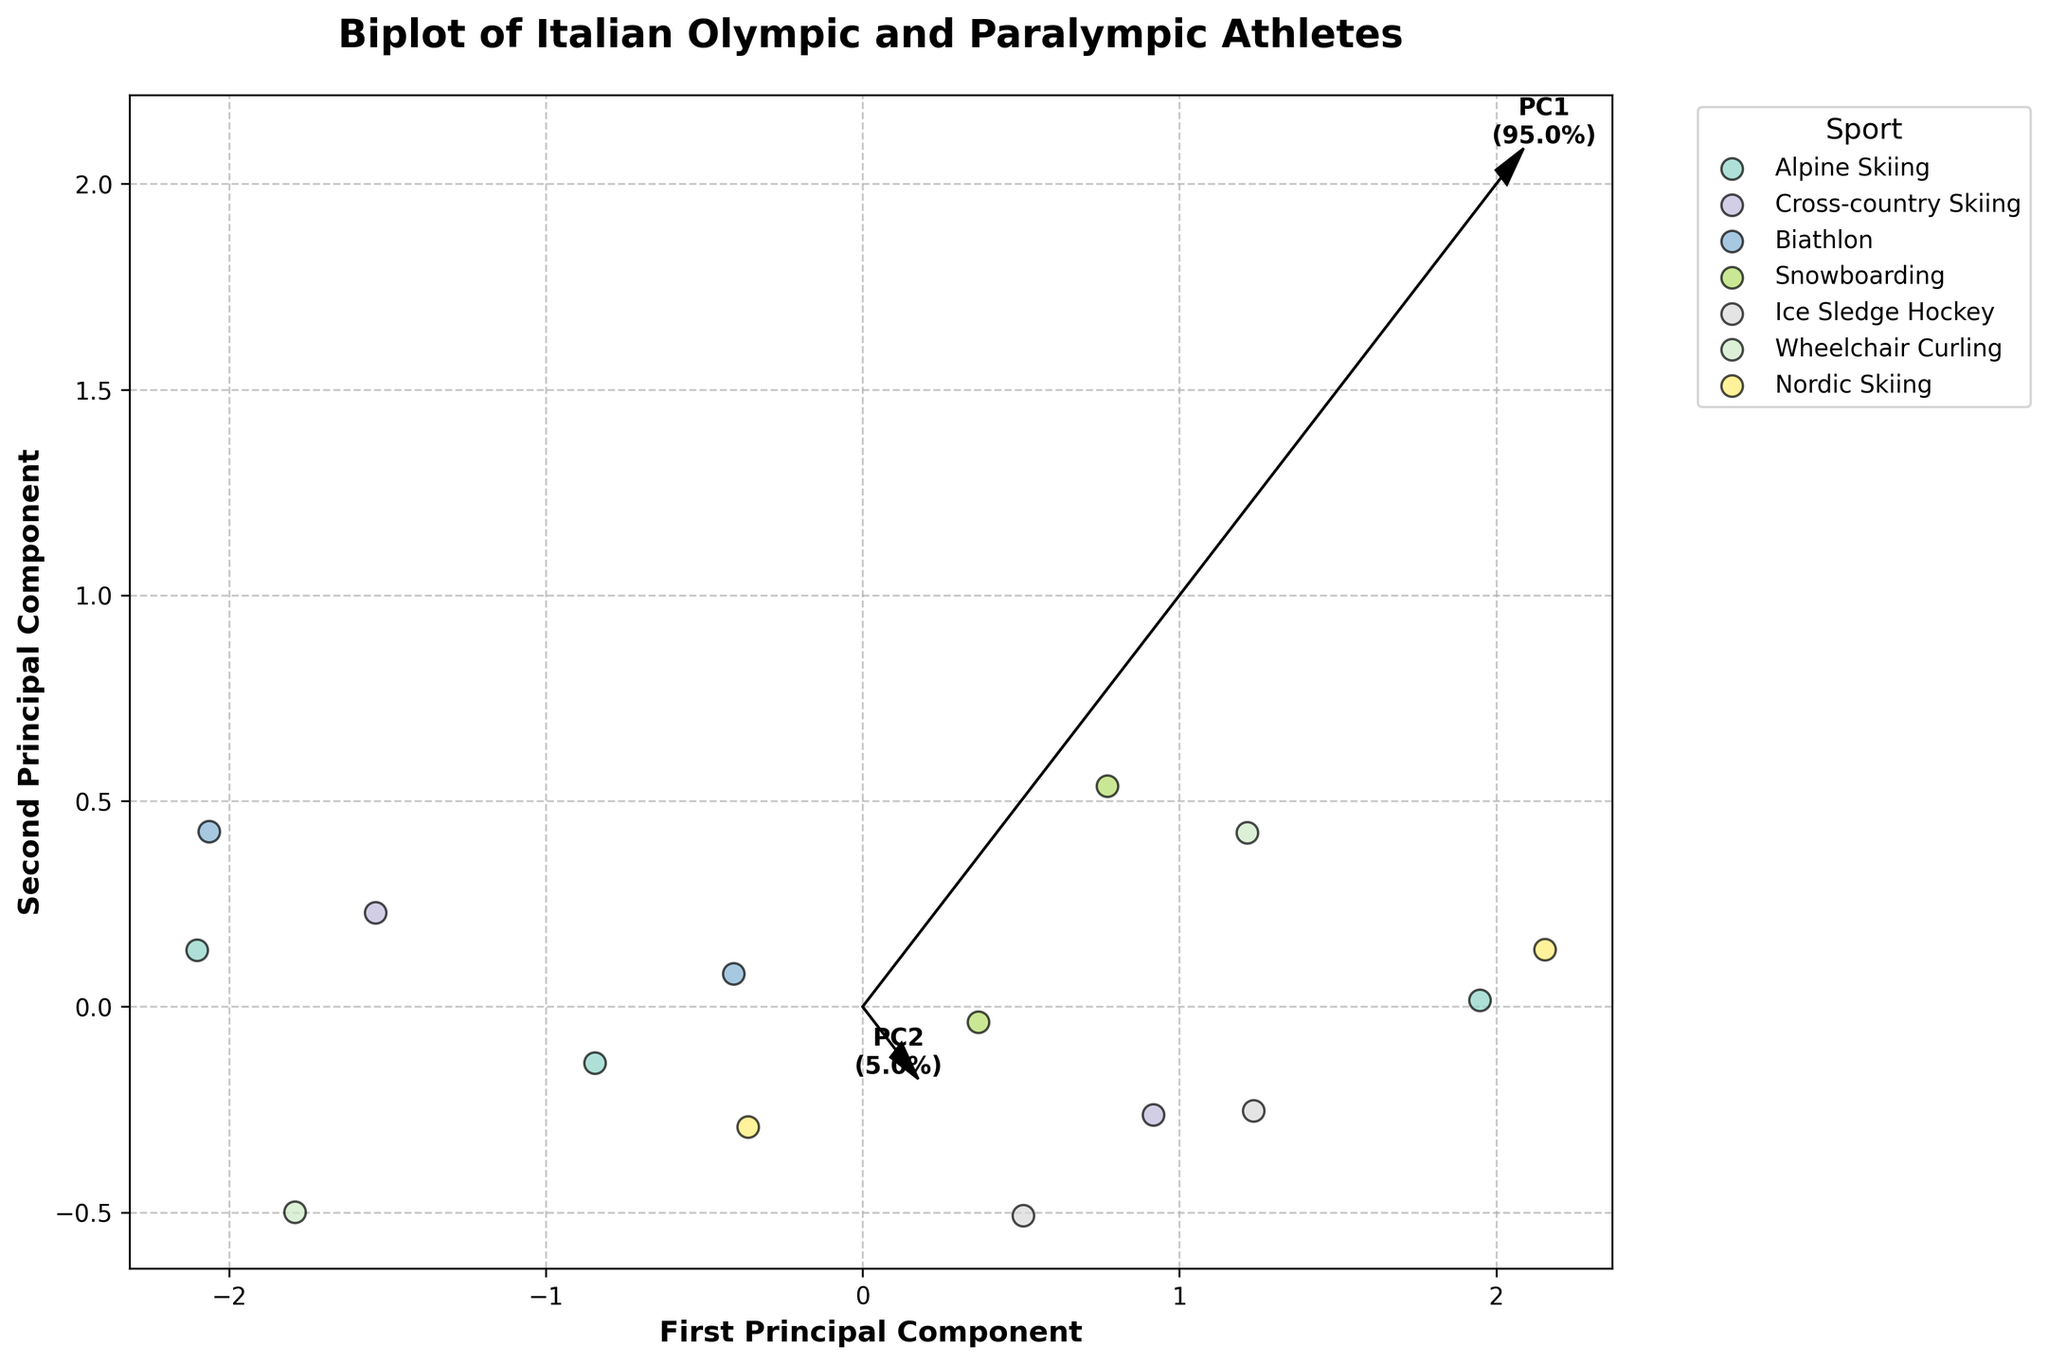Who has a higher performance score in Nordic Skiing, the male athlete or the female athlete? To compare the performance scores of the male and female athletes in Nordic Skiing, locate their corresponding points on the plot. Check the legends which denote the sports. The figures provided show the female had a higher performance score in Nordic Skiing.
Answer: Female Which sport shows the highest performance score in the latest year (2022)? Observe the different colors representing different sports and focus on the data points corresponding to 2022. Compare the performance scores among these points. Nordic Skiing in 2022 has the highest performance score.
Answer: Nordic Skiing Is there a stronger visual correlation between age and performance score with the first principal component or the second principal component? Look at the eigenvectors plotted on the biplot, which indicate the directions of the principal components. Observe their lengths and how aligned the scatter of data points is with each component vector. The first principal component shows a stronger visual correlation with both age and performance score.
Answer: First principal component What proportion of variance is explained by the first principal component? Check the explanation percentages annotated next to the eigenvectors on the plot. The figure provided a percentage for each principal component. The first principal component explains 60.2% of the variance.
Answer: 60.2% Are Male and Female athletes distinguishable on the biplot based on the sports they participate in? To answer this, observe the clusters formed by the different sports and check if the male and female categories overlap significantly or not. Some sports show clear distinction while others overlap; however, in general, it is hard to completely distinguish based only on sports and gender in the biplot.
Answer: Hard to distinguish Which sport shows higher variability, Snowboarding or Alpine Skiing? Check the spread of data points in the figure that represents these two sports and note their positions relative to the principal axes. Snowboarding shows a wider spread in the biplot, indicating higher variability.
Answer: Snowboarding What trend can be observed in the performance scores of 'Ice Sledge Hockey' over the years? Identify the points corresponding to 'Ice Sledge Hockey' using the legend and observe their performance scores across different years. The trend indicates generally high performance scores consistently over the years.
Answer: Consistently high Is the relationship between age and performance score the same for Olympic athletes and Paralympic athletes? Categorize the points based on whether they are Olympic or Paralympic athletes and observe their spread along age and performance score dimensions. The relationships show differing trends, indicating the relationship is not strictly the same.
Answer: Different trends 